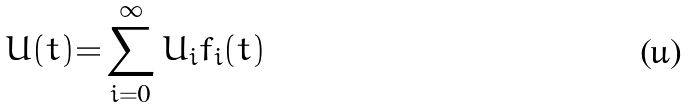<formula> <loc_0><loc_0><loc_500><loc_500>U ( t ) { = } \sum _ { i = 0 } ^ { \infty } U _ { i } f _ { i } ( t )</formula> 